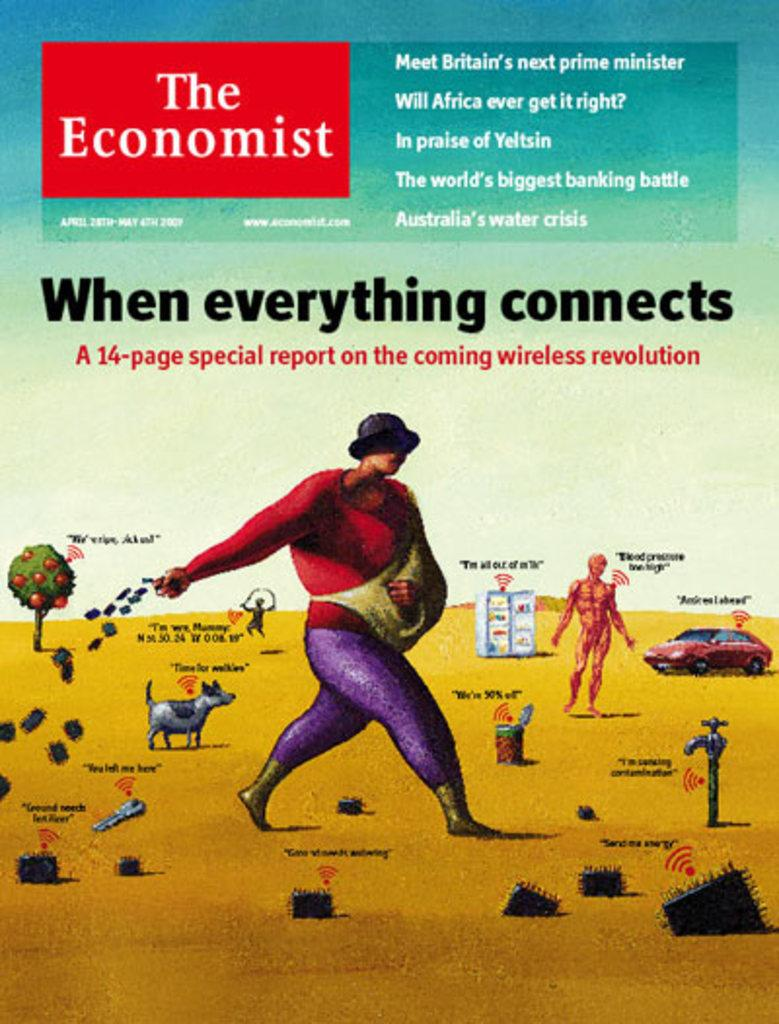What is the main object in the image? There is a pamphlet in the image. Can you describe the person in the image? There is a person in the image. What type of food is visible in the image? There are chips in the image. What is the purpose of the tap in the image? There is a tap in the image. What animal is present in the image? There is a dog in the image. What type of natural scenery is visible in the image? There are trees in the image. What mode of transportation is present in the image? There is a vehicle in the image. What is the color of the box in the image? There is a white box in the image. What is the color of the surface where objects are placed in the image? There are objects on a yellow surface in the image. How would you describe the overall appearance of the image? The image is colorful. How many apples are being harvested by the partner in the image? There are no apples or partners present in the image. 